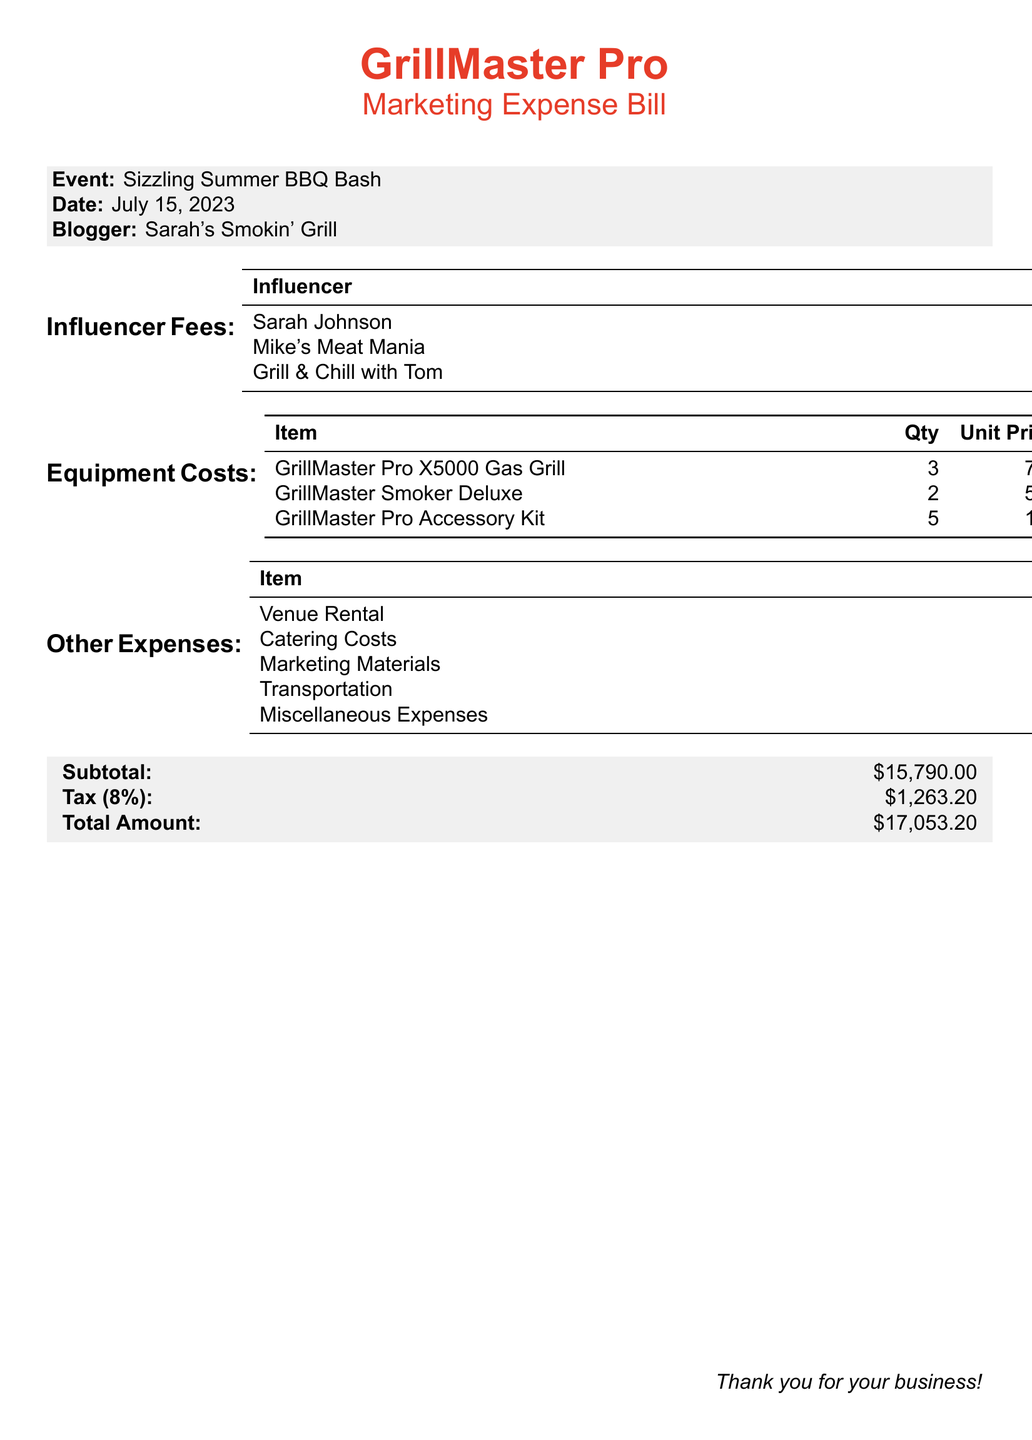what is the event name? The event name is listed at the top of the document under the event description.
Answer: Sizzling Summer BBQ Bash what is the total amount due? The total amount due is at the bottom of the document, summarizing all costs.
Answer: $17,053.20 how many units of the GrillMaster Pro X5000 Gas Grill were purchased? The quantity of this item is specified in the equipment costs section of the document.
Answer: 3 what is the influencer fee paid to Mike's Meat Mania? The fee for this influencer is detailed in the influencer fees table.
Answer: $1,800.00 what category does the venue rental expense fall under? Venue rental is categorized under other expenses in the document.
Answer: Other Expenses what is the subtotal of the expenses before tax? The subtotal amount is presented in the summary section at the bottom.
Answer: $15,790.00 how much was spent on marketing materials? The cost of marketing materials is listed in the other expenses section.
Answer: $800.00 who is the main blogger associated with the event? The main blogger is mentioned directly in the event description of the document.
Answer: Sarah's Smokin' Grill what is the tax rate applied to the subtotal? The tax rate is provided in the summary section, along with the tax calculation.
Answer: 8% 